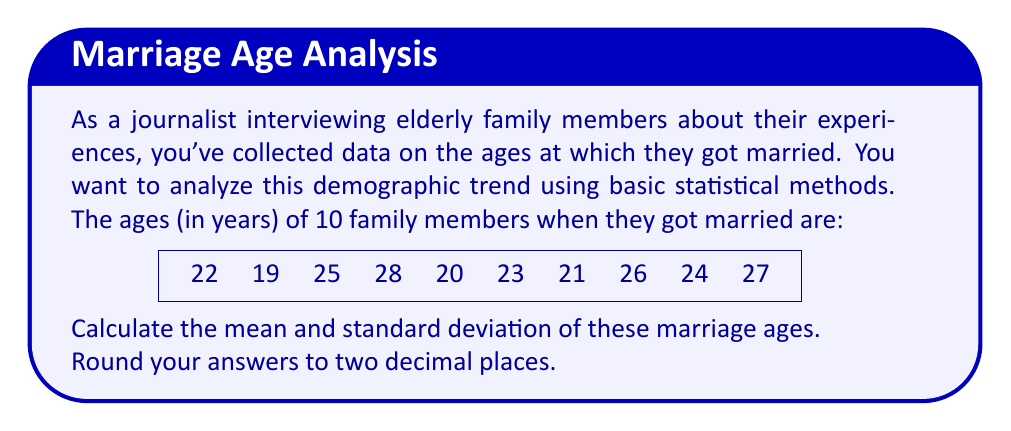Help me with this question. To analyze this demographic trend, we'll calculate the mean and standard deviation of the marriage ages.

Step 1: Calculate the mean (average)
The mean is calculated by summing all values and dividing by the number of values.

$$ \text{Mean} = \frac{\sum_{i=1}^{n} x_i}{n} $$

Where $x_i$ are the individual values and $n$ is the number of values.

$$ \text{Mean} = \frac{22 + 19 + 25 + 28 + 20 + 23 + 21 + 26 + 24 + 27}{10} = \frac{235}{10} = 23.5 $$

Step 2: Calculate the standard deviation
The standard deviation measures the spread of the data. It's calculated using the following formula:

$$ \text{Standard Deviation} = \sqrt{\frac{\sum_{i=1}^{n} (x_i - \bar{x})^2}{n-1}} $$

Where $\bar{x}$ is the mean and $n$ is the number of values.

First, calculate $(x_i - \bar{x})^2$ for each value:
(22 - 23.5)² = (-1.5)² = 2.25
(19 - 23.5)² = (-4.5)² = 20.25
(25 - 23.5)² = (1.5)² = 2.25
(28 - 23.5)² = (4.5)² = 20.25
(20 - 23.5)² = (-3.5)² = 12.25
(23 - 23.5)² = (-0.5)² = 0.25
(21 - 23.5)² = (-2.5)² = 6.25
(26 - 23.5)² = (2.5)² = 6.25
(24 - 23.5)² = (0.5)² = 0.25
(27 - 23.5)² = (3.5)² = 12.25

Sum these values:
2.25 + 20.25 + 2.25 + 20.25 + 12.25 + 0.25 + 6.25 + 6.25 + 0.25 + 12.25 = 82.5

Now, plug this into the formula:

$$ \text{Standard Deviation} = \sqrt{\frac{82.5}{9}} = \sqrt{9.1667} = 3.03 $$

(rounded to two decimal places)
Answer: Mean: 23.50, Standard Deviation: 3.03 